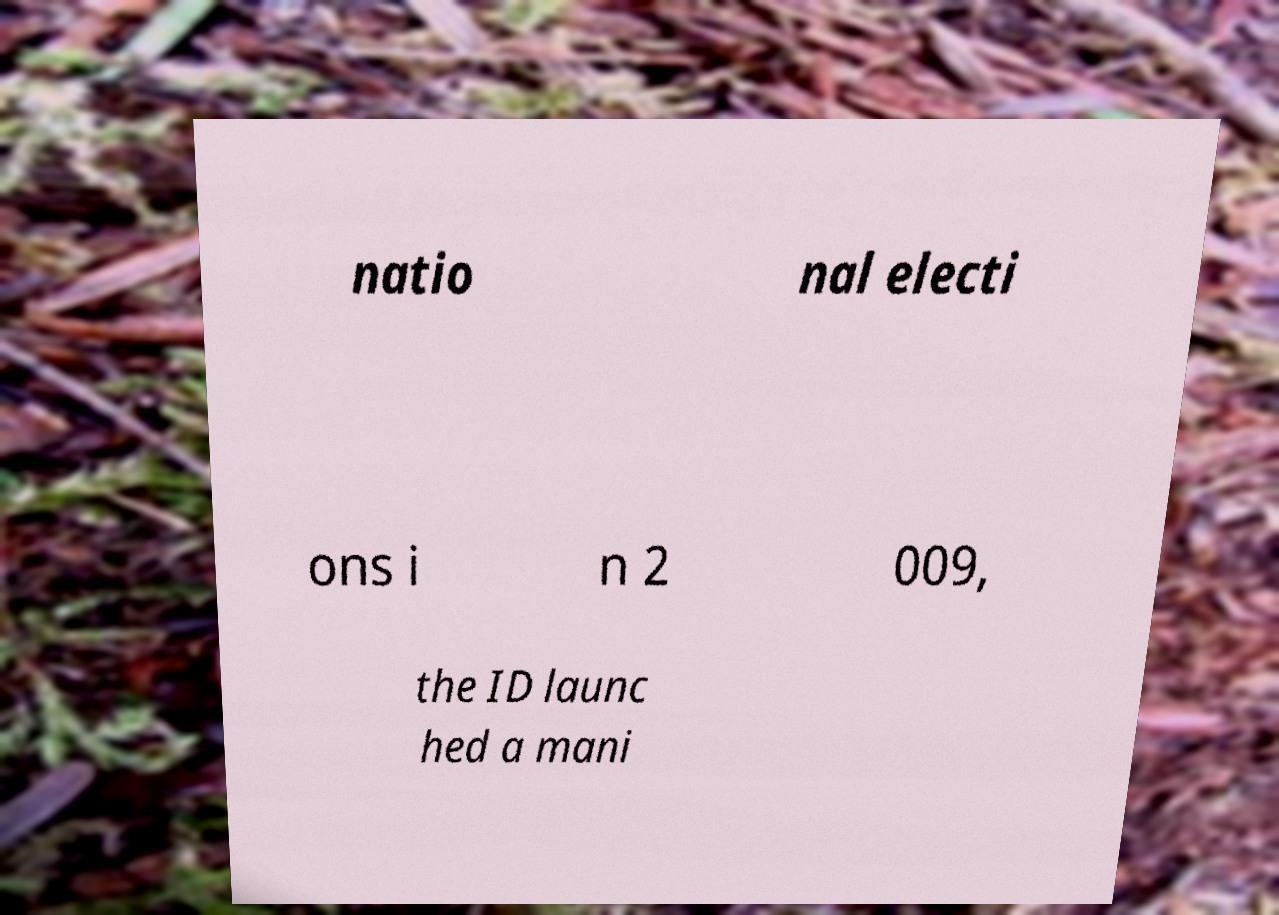Can you read and provide the text displayed in the image?This photo seems to have some interesting text. Can you extract and type it out for me? natio nal electi ons i n 2 009, the ID launc hed a mani 